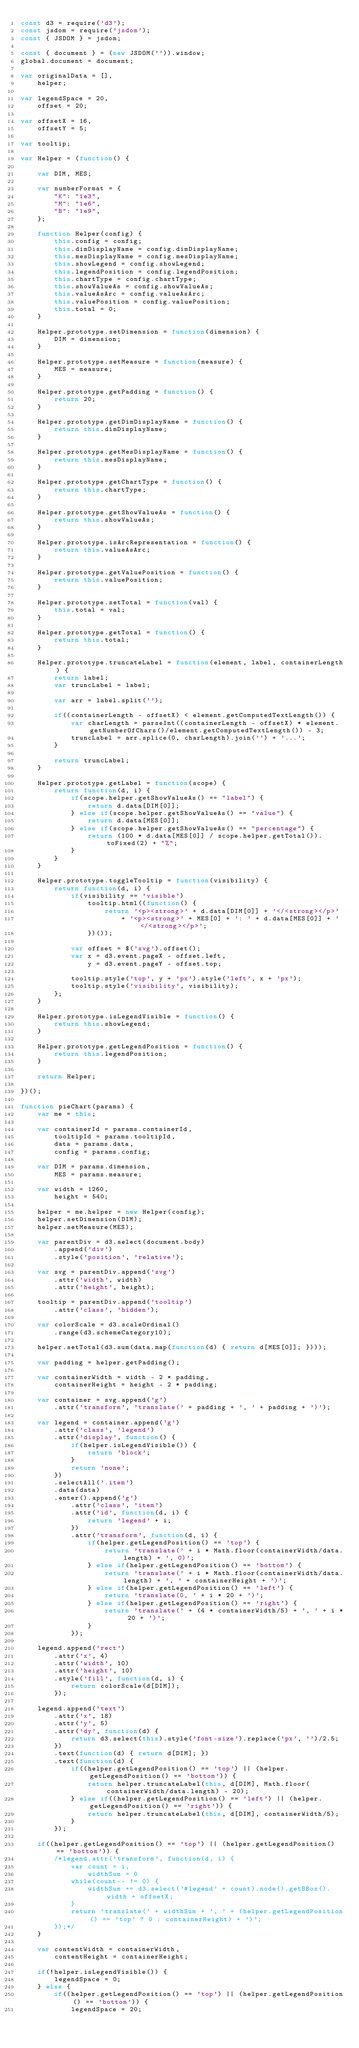<code> <loc_0><loc_0><loc_500><loc_500><_JavaScript_>const d3 = require('d3');
const jsdom = require('jsdom');
const { JSDOM } = jsdom;

const { document } = (new JSDOM('')).window;
global.document = document;

var originalData = [],
    helper;

var legendSpace = 20,
    offset = 20;

var offsetX = 16, 
    offsetY = 5;

var tooltip;

var Helper = (function() {

    var DIM, MES;

    var numberFormat = {
        "K": "1e3",
        "M": "1e6",
        "B": "1e9",
    };

    function Helper(config) {
        this.config = config;
        this.dimDisplayName = config.dimDisplayName;
        this.mesDisplayName = config.mesDisplayName;
        this.showLegend = config.showLegend;
        this.legendPosition = config.legendPosition;
        this.chartType = config.chartType;
        this.showValueAs = config.showValueAs;
        this.valueAsArc = config.valueAsArc;
        this.valuePosition = config.valuePosition;
        this.total = 0;
    }

    Helper.prototype.setDimension = function(dimension) {
        DIM = dimension;
    }

    Helper.prototype.setMeasure = function(measure) {
        MES = measure;
    }

    Helper.prototype.getPadding = function() {
        return 20;
    }

    Helper.prototype.getDimDisplayName = function() {
        return this.dimDisplayName;
    }

    Helper.prototype.getMesDisplayName = function() {
        return this.mesDisplayName;
    }

    Helper.prototype.getChartType = function() {
        return this.chartType;
    }

    Helper.prototype.getShowValueAs = function() {
        return this.showValueAs;
    }

    Helper.prototype.isArcRepresentation = function() {
        return this.valueAsArc;
    }

    Helper.prototype.getValuePosition = function() {
        return this.valuePosition;
    }

    Helper.prototype.setTotal = function(val) {
        this.total = val;
    }

    Helper.prototype.getTotal = function() {
        return this.total;
    }

    Helper.prototype.truncateLabel = function(element, label, containerLength) {
        return label;
        var truncLabel = label;

        var arr = label.split('');

        if((containerLength - offsetX) < element.getComputedTextLength()) {
            var charLength = parseInt((containerLength - offsetX) * element.getNumberOfChars()/element.getComputedTextLength()) - 3;
            truncLabel = arr.splice(0, charLength).join('') + '...';    
        }

        return truncLabel;
    }

    Helper.prototype.getLabel = function(scope) {
        return function(d, i) {
            if(scope.helper.getShowValueAs() == "label") {
                return d.data[DIM[0]];
            } else if(scope.helper.getShowValueAs() == "value") {
                return d.data[MES[0]];
            } else if(scope.helper.getShowValueAs() == "percentage") {
                return (100 * d.data[MES[0]] / scope.helper.getTotal()).toFixed(2) + "%";
            }
        }
    }

    Helper.prototype.toggleTooltip = function(visibility) {
        return function(d, i) {
            if(visibility == 'visible')
                tooltip.html((function() {
                    return '<p><strong>' + d.data[DIM[0]] + '</<strong></p>'
                        + '<p><strong>' + MES[0] + ': ' + d.data[MES[0]] + '</<strong></p>';
                })());

            var offset = $('svg').offset();
            var x = d3.event.pageX - offset.left,
                y = d3.event.pageY - offset.top;

            tooltip.style('top', y + 'px').style('left', x + 'px');
            tooltip.style('visibility', visibility);
        };
    }

    Helper.prototype.isLegendVisible = function() {
        return this.showLegend;
    }

    Helper.prototype.getLegendPosition = function() {
        return this.legendPosition;
    }

    return Helper;

})();

function pieChart(params) {
    var me = this;

    var containerId = params.containerId,
        tooltipId = params.tooltipId,
        data = params.data,
        config = params.config;

    var DIM = params.dimension,
        MES = params.measure;

    var width = 1260,
        height = 540;

    helper = me.helper = new Helper(config);
    helper.setDimension(DIM);
    helper.setMeasure(MES);

    var parentDiv = d3.select(document.body)
        .append('div')
        .style('position', 'relative');

    var svg = parentDiv.append('svg')
        .attr('width', width)
        .attr('height', height);

    tooltip = parentDiv.append('tooltip')
        .attr('class', 'hidden');

    var colorScale = d3.scaleOrdinal()
        .range(d3.schemeCategory10);

    helper.setTotal(d3.sum(data.map(function(d) { return d[MES[0]]; })));

    var padding = helper.getPadding();

    var containerWidth = width - 2 * padding,
        containerHeight = height - 2 * padding;

    var container = svg.append('g')
        .attr('transform', 'translate(' + padding + ', ' + padding + ')');

    var legend = container.append('g')
        .attr('class', 'legend')
        .attr('display', function() {
            if(helper.isLegendVisible()) {
                return 'block';
            }
            return 'none';
        })
        .selectAll('.item')
        .data(data)
        .enter().append('g')
            .attr('class', 'item')
            .attr('id', function(d, i) {
                return 'legend' + i;
            })
            .attr('transform', function(d, i) {
                if(helper.getLegendPosition() == 'top') {
                    return 'translate(' + i * Math.floor(containerWidth/data.length) + ', 0)';
                } else if(helper.getLegendPosition() == 'bottom') {
                    return 'translate(' + i * Math.floor(containerWidth/data.length) + ', ' + containerHeight + ')';
                } else if(helper.getLegendPosition() == 'left') {
                    return 'translate(0, ' + i * 20 + ')';
                } else if(helper.getLegendPosition() == 'right') {
                    return 'translate(' + (4 * containerWidth/5) + ', ' + i * 20 + ')';
                }
            });

    legend.append('rect')
        .attr('x', 4)
        .attr('width', 10)
        .attr('height', 10)
        .style('fill', function(d, i) {
            return colorScale(d[DIM]);
        });

    legend.append('text')
        .attr('x', 18)
        .attr('y', 5)
        .attr('dy', function(d) {
            return d3.select(this).style('font-size').replace('px', '')/2.5;
        })
        .text(function(d) { return d[DIM]; })
        .text(function(d) {
            if((helper.getLegendPosition() == 'top') || (helper.getLegendPosition() == 'bottom')) {
                return helper.truncateLabel(this, d[DIM], Math.floor(containerWidth/data.length) - 20);
            } else if((helper.getLegendPosition() == 'left') || (helper.getLegendPosition() == 'right')) {
                return helper.truncateLabel(this, d[DIM], containerWidth/5);
            }
        });

    if((helper.getLegendPosition() == 'top') || (helper.getLegendPosition() == 'bottom')) {
        /*legend.attr('transform', function(d, i) {
            var count = i,
                widthSum = 0
            while(count-- != 0) {
                widthSum += d3.select('#legend' + count).node().getBBox().width + offsetX;
            }
            return 'translate(' + widthSum + ', ' + (helper.getLegendPosition() == 'top' ? 0 : containerHeight) + ')';
        });*/
    }

    var contentWidth = containerWidth,
        contentHeight = containerHeight;

    if(!helper.isLegendVisible()) {
        legendSpace = 0;
    } else {
        if((helper.getLegendPosition() == 'top') || (helper.getLegendPosition() == 'bottom')) {
            legendSpace = 20;</code> 